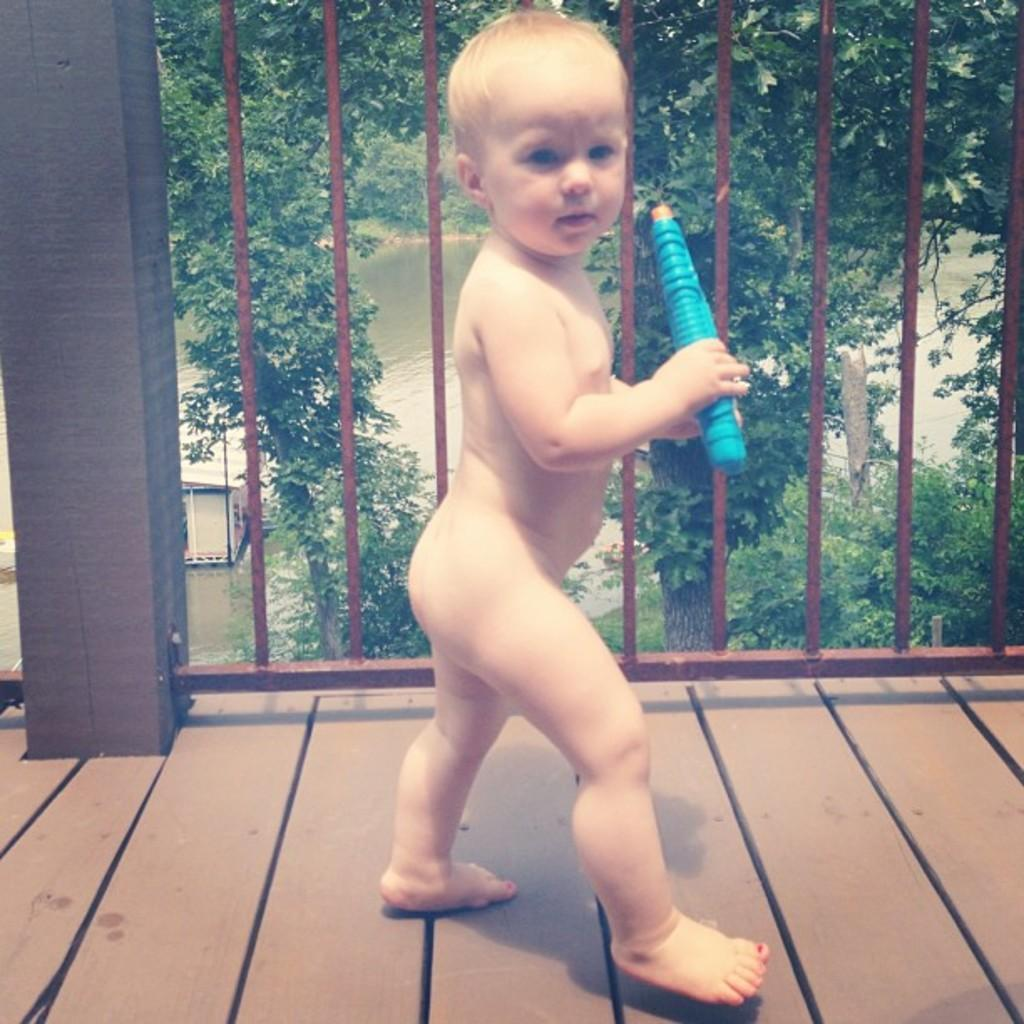What is the main subject of the image? There is a kid standing in the image. What is the kid holding in the image? The kid is holding an object. What can be seen in the background of the image? There is water, a house, iron grilles, and trees visible in the background of the image. What type of wire can be seen hanging from the trees in the image? There is no wire hanging from the trees in the image. What type of eggnog is being served in the alley behind the house in the image? There is no alley or eggnog present in the image. 